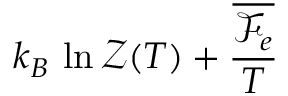<formula> <loc_0><loc_0><loc_500><loc_500>k _ { B } \, \ln \mathcal { Z } ( T ) + \frac { \overline { { \mathcal { F } _ { e } } } } { T }</formula> 